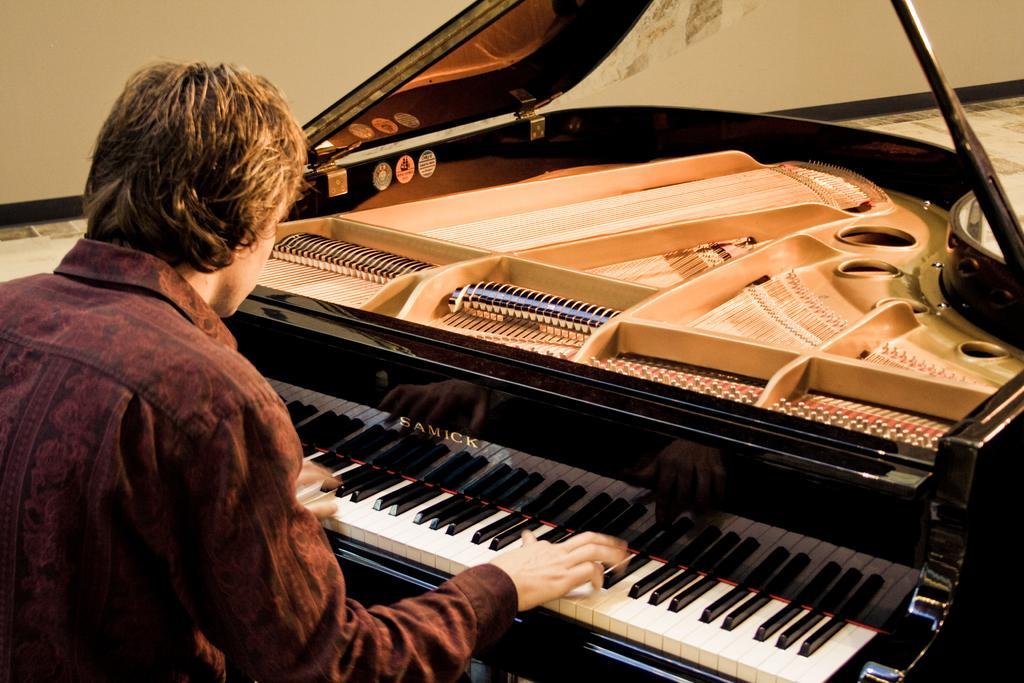Can you describe this image briefly? In this image the person is playing the piano and wearing the brown shirt and piano's color is also brown. 